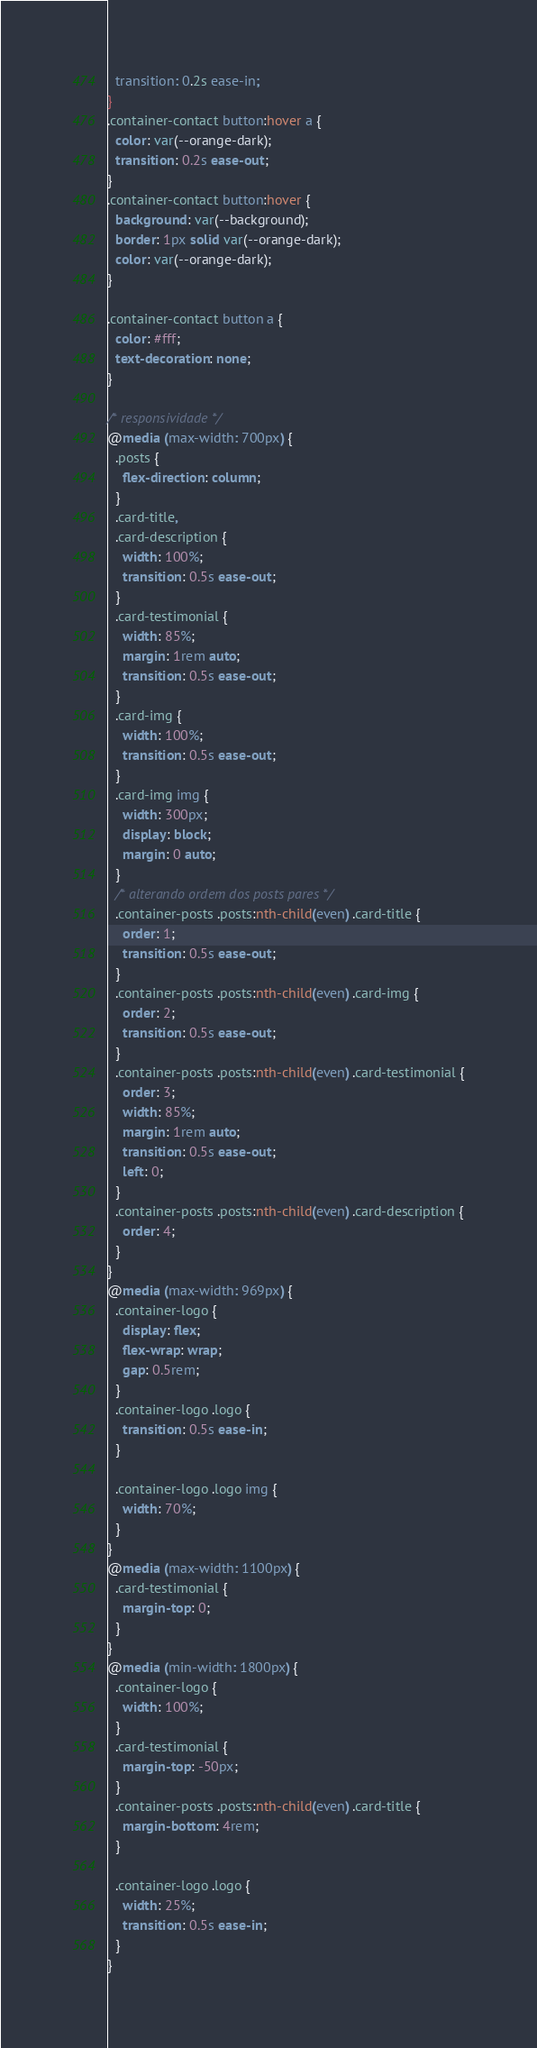<code> <loc_0><loc_0><loc_500><loc_500><_CSS_>  transition: 0.2s ease-in;
}
.container-contact button:hover a {
  color: var(--orange-dark);
  transition: 0.2s ease-out;
}
.container-contact button:hover {
  background: var(--background);
  border: 1px solid var(--orange-dark);
  color: var(--orange-dark);
}

.container-contact button a {
  color: #fff;
  text-decoration: none;
}

/* responsividade */
@media (max-width: 700px) {
  .posts {
    flex-direction: column;
  }
  .card-title,
  .card-description {
    width: 100%;
    transition: 0.5s ease-out;
  }
  .card-testimonial {
    width: 85%;
    margin: 1rem auto;
    transition: 0.5s ease-out;
  }
  .card-img {
    width: 100%;
    transition: 0.5s ease-out;
  }
  .card-img img {
    width: 300px;
    display: block;
    margin: 0 auto;
  }
  /* alterando ordem dos posts pares */
  .container-posts .posts:nth-child(even) .card-title {
    order: 1;
    transition: 0.5s ease-out;
  }
  .container-posts .posts:nth-child(even) .card-img {
    order: 2;
    transition: 0.5s ease-out;
  }
  .container-posts .posts:nth-child(even) .card-testimonial {
    order: 3;
    width: 85%;
    margin: 1rem auto;
    transition: 0.5s ease-out;
    left: 0;
  }
  .container-posts .posts:nth-child(even) .card-description {
    order: 4;
  }
}
@media (max-width: 969px) {
  .container-logo {
    display: flex;
    flex-wrap: wrap;
    gap: 0.5rem;
  }
  .container-logo .logo {
    transition: 0.5s ease-in;
  }

  .container-logo .logo img {
    width: 70%;
  }
}
@media (max-width: 1100px) {
  .card-testimonial {
    margin-top: 0;
  }
}
@media (min-width: 1800px) {
  .container-logo {
    width: 100%;
  }
  .card-testimonial {
    margin-top: -50px;
  }
  .container-posts .posts:nth-child(even) .card-title {
    margin-bottom: 4rem;
  }

  .container-logo .logo {
    width: 25%;
    transition: 0.5s ease-in;
  }
}
</code> 